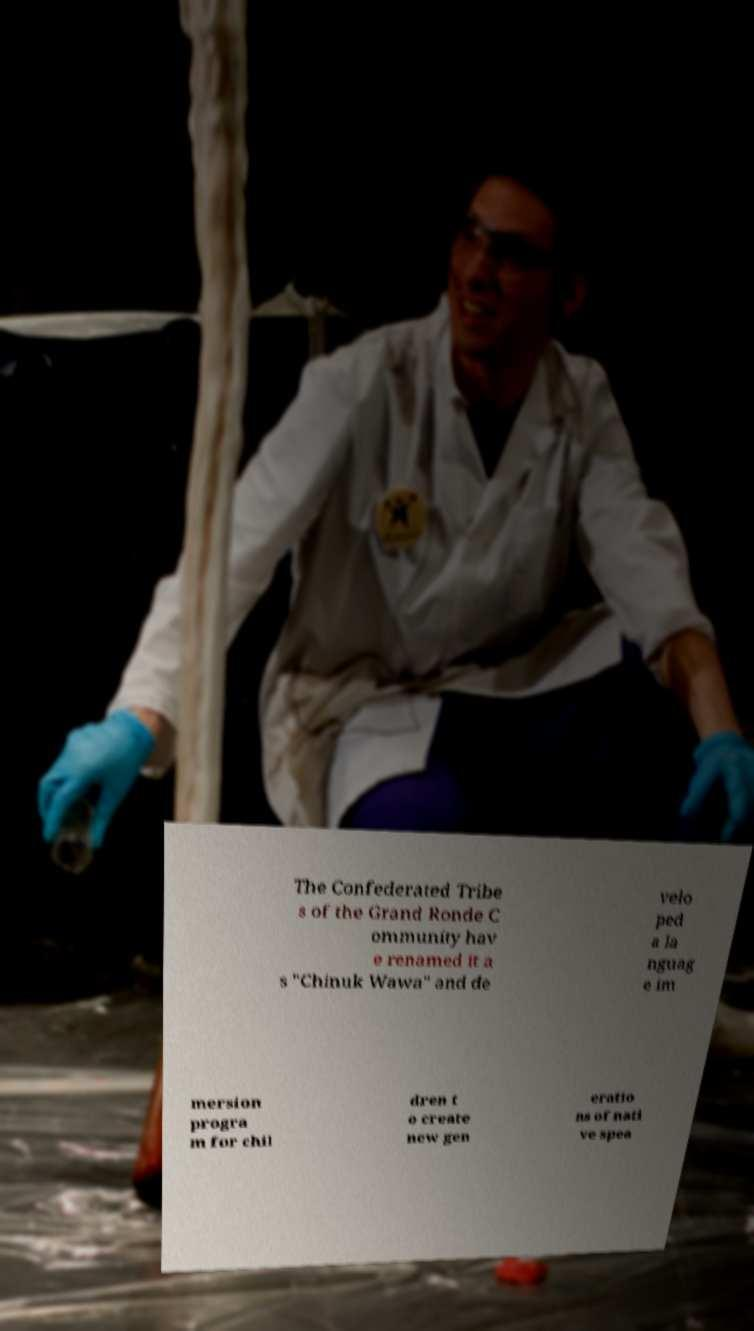What messages or text are displayed in this image? I need them in a readable, typed format. The Confederated Tribe s of the Grand Ronde C ommunity hav e renamed it a s "Chinuk Wawa" and de velo ped a la nguag e im mersion progra m for chil dren t o create new gen eratio ns of nati ve spea 